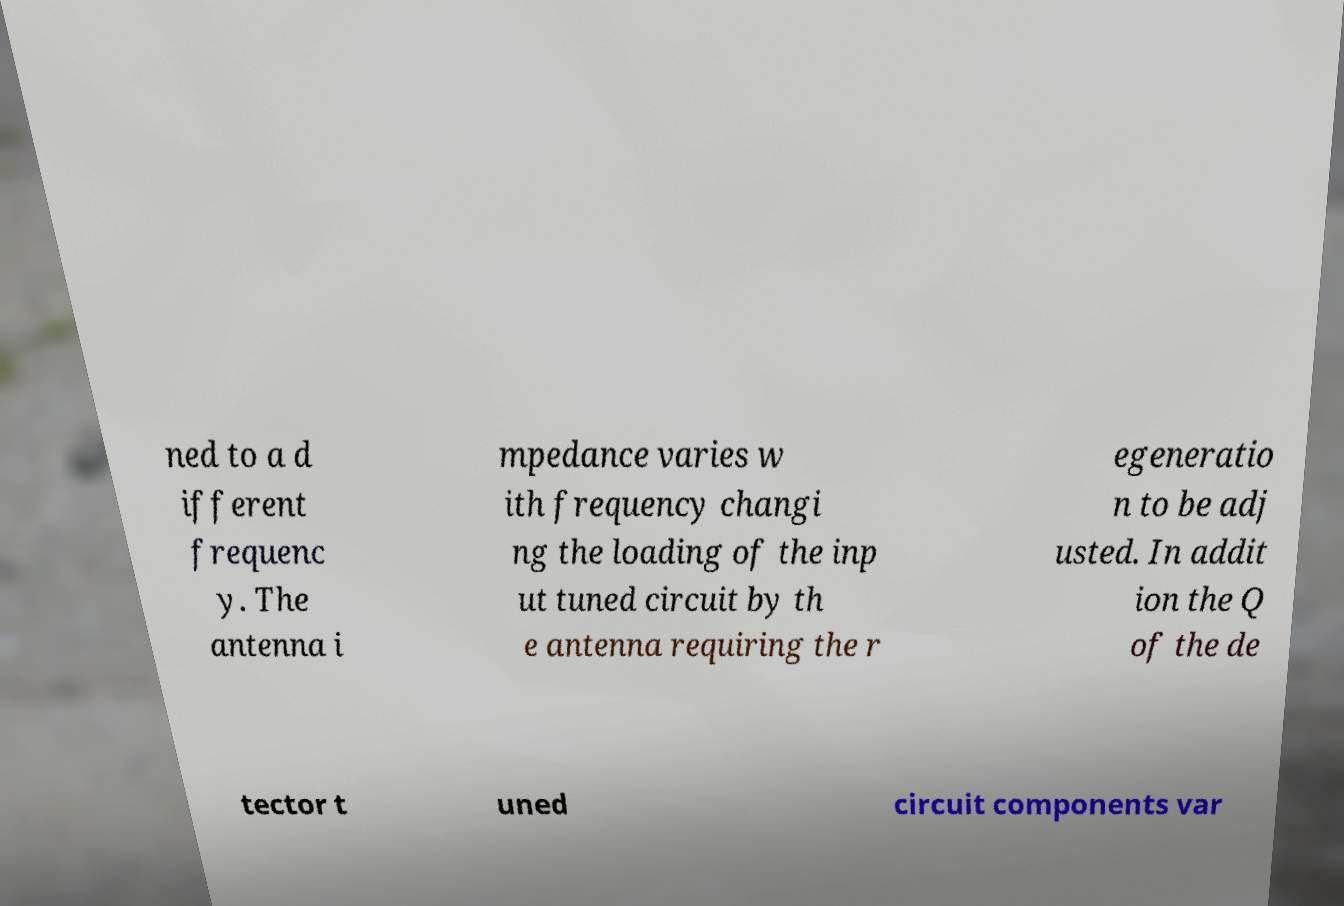For documentation purposes, I need the text within this image transcribed. Could you provide that? ned to a d ifferent frequenc y. The antenna i mpedance varies w ith frequency changi ng the loading of the inp ut tuned circuit by th e antenna requiring the r egeneratio n to be adj usted. In addit ion the Q of the de tector t uned circuit components var 